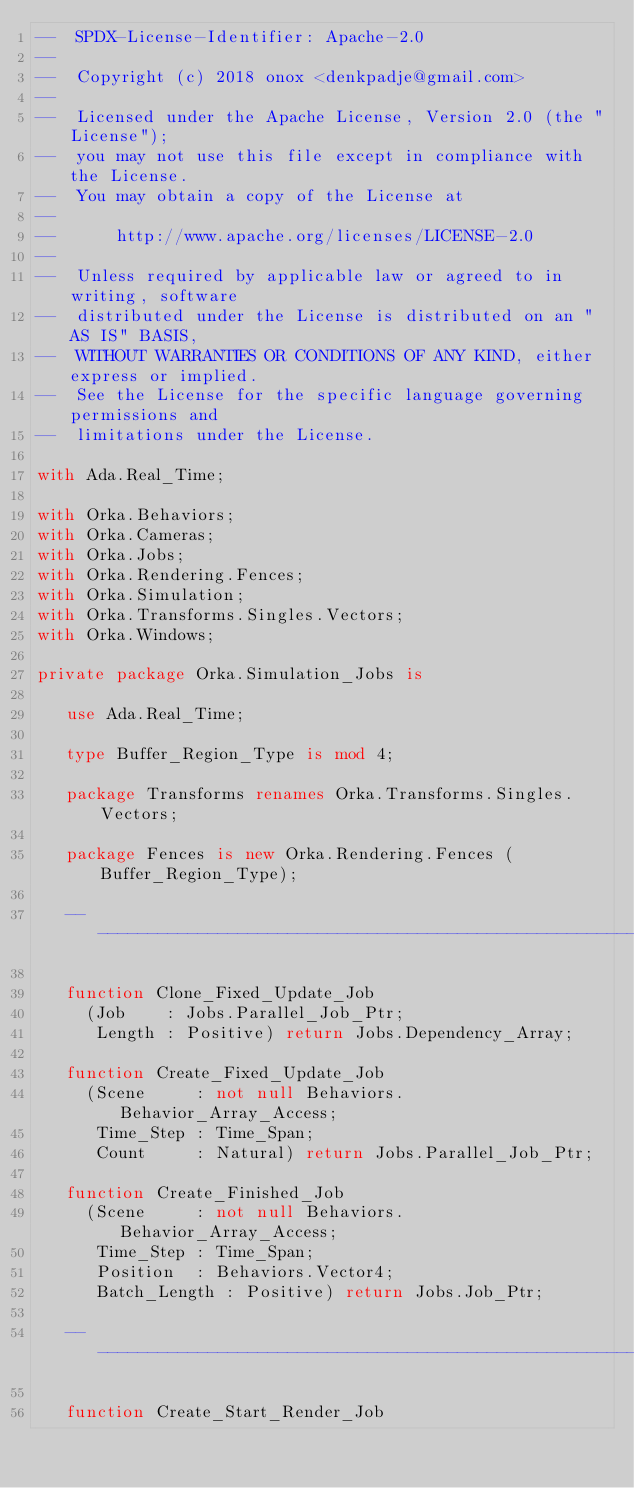<code> <loc_0><loc_0><loc_500><loc_500><_Ada_>--  SPDX-License-Identifier: Apache-2.0
--
--  Copyright (c) 2018 onox <denkpadje@gmail.com>
--
--  Licensed under the Apache License, Version 2.0 (the "License");
--  you may not use this file except in compliance with the License.
--  You may obtain a copy of the License at
--
--      http://www.apache.org/licenses/LICENSE-2.0
--
--  Unless required by applicable law or agreed to in writing, software
--  distributed under the License is distributed on an "AS IS" BASIS,
--  WITHOUT WARRANTIES OR CONDITIONS OF ANY KIND, either express or implied.
--  See the License for the specific language governing permissions and
--  limitations under the License.

with Ada.Real_Time;

with Orka.Behaviors;
with Orka.Cameras;
with Orka.Jobs;
with Orka.Rendering.Fences;
with Orka.Simulation;
with Orka.Transforms.Singles.Vectors;
with Orka.Windows;

private package Orka.Simulation_Jobs is

   use Ada.Real_Time;

   type Buffer_Region_Type is mod 4;

   package Transforms renames Orka.Transforms.Singles.Vectors;

   package Fences is new Orka.Rendering.Fences (Buffer_Region_Type);

   -----------------------------------------------------------------------------

   function Clone_Fixed_Update_Job
     (Job    : Jobs.Parallel_Job_Ptr;
      Length : Positive) return Jobs.Dependency_Array;

   function Create_Fixed_Update_Job
     (Scene     : not null Behaviors.Behavior_Array_Access;
      Time_Step : Time_Span;
      Count     : Natural) return Jobs.Parallel_Job_Ptr;

   function Create_Finished_Job
     (Scene     : not null Behaviors.Behavior_Array_Access;
      Time_Step : Time_Span;
      Position  : Behaviors.Vector4;
      Batch_Length : Positive) return Jobs.Job_Ptr;

   -----------------------------------------------------------------------------

   function Create_Start_Render_Job</code> 